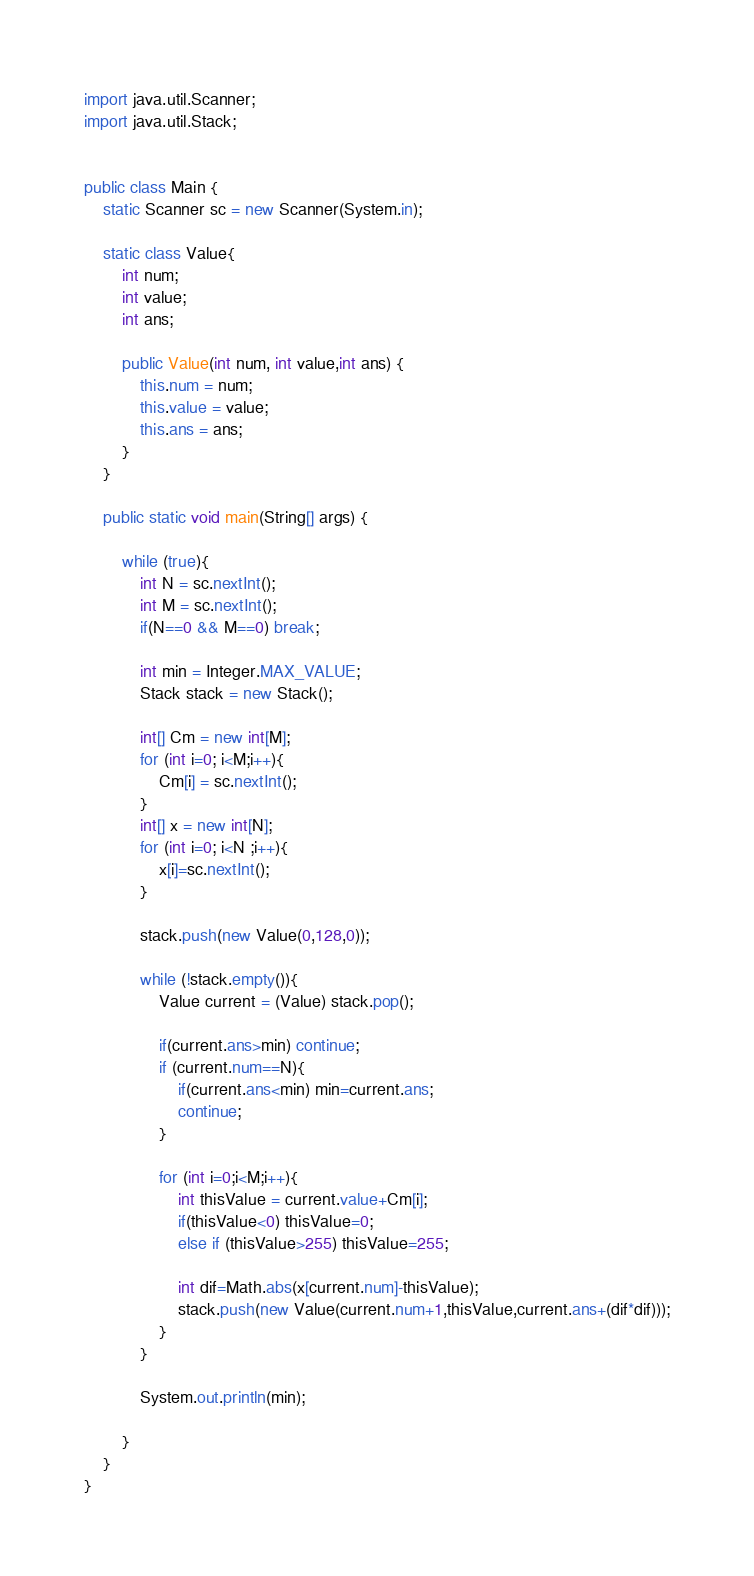Convert code to text. <code><loc_0><loc_0><loc_500><loc_500><_Java_>import java.util.Scanner;
import java.util.Stack;


public class Main {
    static Scanner sc = new Scanner(System.in);

    static class Value{
        int num;
        int value;
        int ans;

        public Value(int num, int value,int ans) {
            this.num = num;
            this.value = value;
            this.ans = ans;
        }
    }

    public static void main(String[] args) {

        while (true){
            int N = sc.nextInt();
            int M = sc.nextInt();
            if(N==0 && M==0) break;

            int min = Integer.MAX_VALUE;
            Stack stack = new Stack();

            int[] Cm = new int[M];
            for (int i=0; i<M;i++){
                Cm[i] = sc.nextInt();
            }
            int[] x = new int[N];
            for (int i=0; i<N ;i++){
                x[i]=sc.nextInt();
            }

            stack.push(new Value(0,128,0));

            while (!stack.empty()){
                Value current = (Value) stack.pop();

                if(current.ans>min) continue;
                if (current.num==N){
                    if(current.ans<min) min=current.ans;
                    continue;
                }

                for (int i=0;i<M;i++){
                    int thisValue = current.value+Cm[i];
                    if(thisValue<0) thisValue=0;
                    else if (thisValue>255) thisValue=255;

                    int dif=Math.abs(x[current.num]-thisValue);
                    stack.push(new Value(current.num+1,thisValue,current.ans+(dif*dif)));
                }
            }

            System.out.println(min);

        }
    }
}</code> 